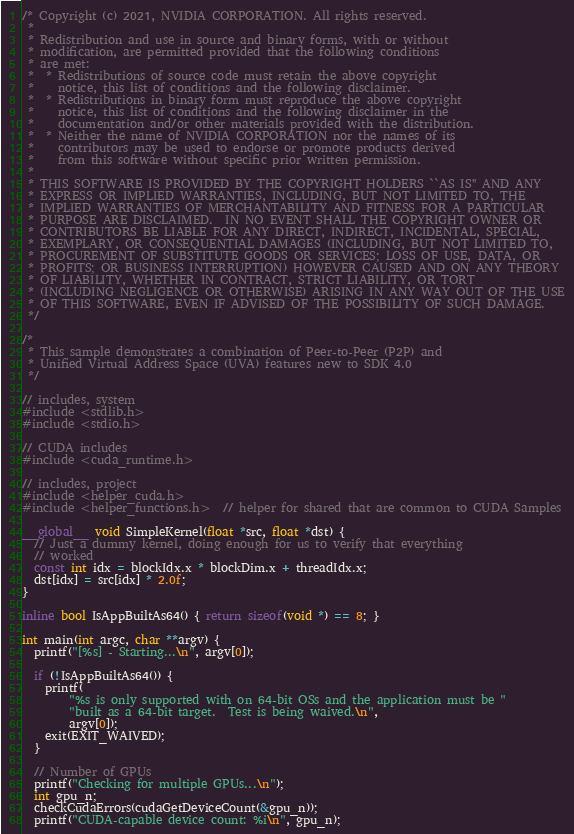<code> <loc_0><loc_0><loc_500><loc_500><_Cuda_>/* Copyright (c) 2021, NVIDIA CORPORATION. All rights reserved.
 *
 * Redistribution and use in source and binary forms, with or without
 * modification, are permitted provided that the following conditions
 * are met:
 *  * Redistributions of source code must retain the above copyright
 *    notice, this list of conditions and the following disclaimer.
 *  * Redistributions in binary form must reproduce the above copyright
 *    notice, this list of conditions and the following disclaimer in the
 *    documentation and/or other materials provided with the distribution.
 *  * Neither the name of NVIDIA CORPORATION nor the names of its
 *    contributors may be used to endorse or promote products derived
 *    from this software without specific prior written permission.
 *
 * THIS SOFTWARE IS PROVIDED BY THE COPYRIGHT HOLDERS ``AS IS'' AND ANY
 * EXPRESS OR IMPLIED WARRANTIES, INCLUDING, BUT NOT LIMITED TO, THE
 * IMPLIED WARRANTIES OF MERCHANTABILITY AND FITNESS FOR A PARTICULAR
 * PURPOSE ARE DISCLAIMED.  IN NO EVENT SHALL THE COPYRIGHT OWNER OR
 * CONTRIBUTORS BE LIABLE FOR ANY DIRECT, INDIRECT, INCIDENTAL, SPECIAL,
 * EXEMPLARY, OR CONSEQUENTIAL DAMAGES (INCLUDING, BUT NOT LIMITED TO,
 * PROCUREMENT OF SUBSTITUTE GOODS OR SERVICES; LOSS OF USE, DATA, OR
 * PROFITS; OR BUSINESS INTERRUPTION) HOWEVER CAUSED AND ON ANY THEORY
 * OF LIABILITY, WHETHER IN CONTRACT, STRICT LIABILITY, OR TORT
 * (INCLUDING NEGLIGENCE OR OTHERWISE) ARISING IN ANY WAY OUT OF THE USE
 * OF THIS SOFTWARE, EVEN IF ADVISED OF THE POSSIBILITY OF SUCH DAMAGE.
 */

/*
 * This sample demonstrates a combination of Peer-to-Peer (P2P) and
 * Unified Virtual Address Space (UVA) features new to SDK 4.0
 */

// includes, system
#include <stdlib.h>
#include <stdio.h>

// CUDA includes
#include <cuda_runtime.h>

// includes, project
#include <helper_cuda.h>
#include <helper_functions.h>  // helper for shared that are common to CUDA Samples

__global__ void SimpleKernel(float *src, float *dst) {
  // Just a dummy kernel, doing enough for us to verify that everything
  // worked
  const int idx = blockIdx.x * blockDim.x + threadIdx.x;
  dst[idx] = src[idx] * 2.0f;
}

inline bool IsAppBuiltAs64() { return sizeof(void *) == 8; }

int main(int argc, char **argv) {
  printf("[%s] - Starting...\n", argv[0]);

  if (!IsAppBuiltAs64()) {
    printf(
        "%s is only supported with on 64-bit OSs and the application must be "
        "built as a 64-bit target.  Test is being waived.\n",
        argv[0]);
    exit(EXIT_WAIVED);
  }

  // Number of GPUs
  printf("Checking for multiple GPUs...\n");
  int gpu_n;
  checkCudaErrors(cudaGetDeviceCount(&gpu_n));
  printf("CUDA-capable device count: %i\n", gpu_n);
</code> 